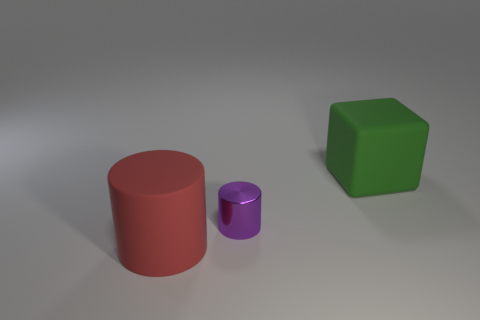What is the shape of the big object left of the green object?
Your answer should be compact. Cylinder. What material is the purple thing?
Make the answer very short. Metal. What color is the matte cube that is the same size as the matte cylinder?
Your answer should be compact. Green. Do the small shiny thing and the red object have the same shape?
Offer a very short reply. Yes. What is the material of the thing that is on the left side of the green block and behind the red thing?
Your answer should be very brief. Metal. How big is the green block?
Make the answer very short. Large. What is the color of the small thing that is the same shape as the large red rubber object?
Your response must be concise. Purple. Are there any other things of the same color as the large matte cube?
Make the answer very short. No. There is a matte thing that is to the right of the red cylinder; is it the same size as the cylinder that is in front of the small purple shiny object?
Give a very brief answer. Yes. Are there the same number of metal cylinders that are to the left of the large red rubber cylinder and large green rubber objects that are right of the big block?
Your answer should be very brief. Yes. 